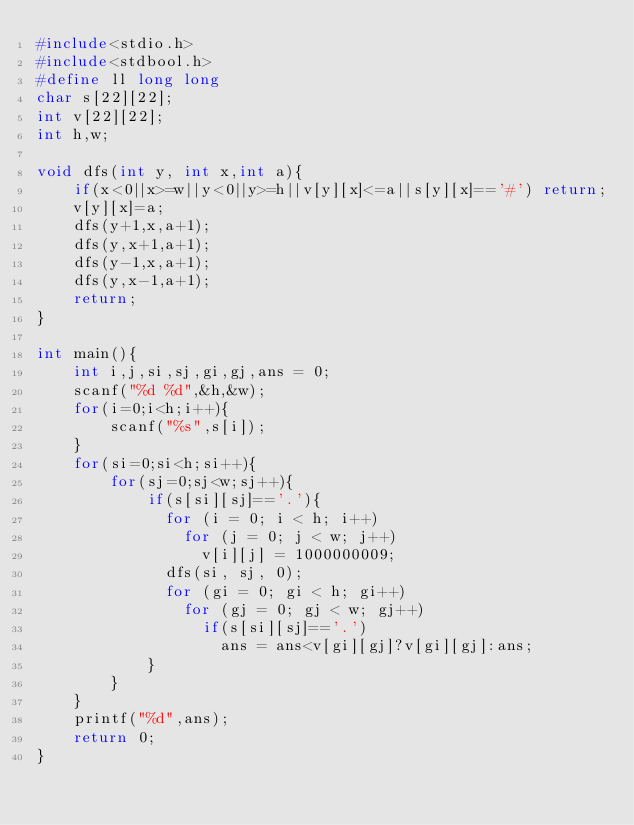<code> <loc_0><loc_0><loc_500><loc_500><_C_>#include<stdio.h>
#include<stdbool.h>
#define ll long long 
char s[22][22];
int v[22][22];
int h,w;

void dfs(int y, int x,int a){
    if(x<0||x>=w||y<0||y>=h||v[y][x]<=a||s[y][x]=='#') return;
    v[y][x]=a;
    dfs(y+1,x,a+1);
    dfs(y,x+1,a+1);
    dfs(y-1,x,a+1);
    dfs(y,x-1,a+1);
    return;
}

int main(){
    int i,j,si,sj,gi,gj,ans = 0;
    scanf("%d %d",&h,&w);
    for(i=0;i<h;i++){
        scanf("%s",s[i]);
    }
    for(si=0;si<h;si++){
        for(sj=0;sj<w;sj++){
            if(s[si][sj]=='.'){
              for (i = 0; i < h; i++)
                for (j = 0; j < w; j++)
                  v[i][j] = 1000000009;
              dfs(si, sj, 0);
              for (gi = 0; gi < h; gi++)
                for (gj = 0; gj < w; gj++)
                  if(s[si][sj]=='.')
                    ans = ans<v[gi][gj]?v[gi][gj]:ans;
            }
        }
    }
    printf("%d",ans);
    return 0;
}</code> 